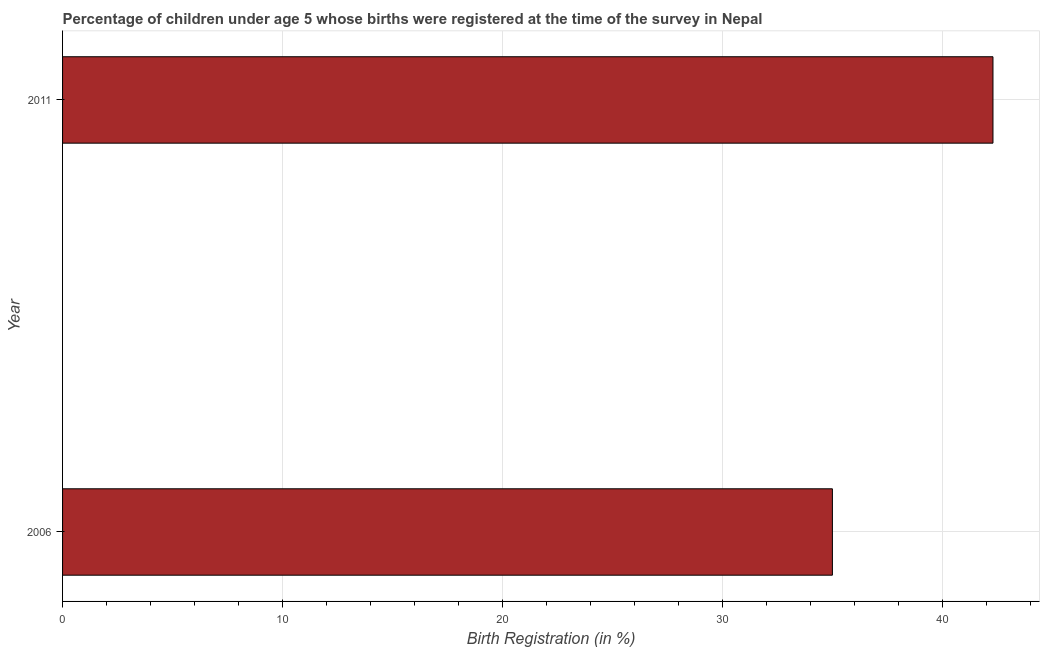Does the graph contain any zero values?
Offer a terse response. No. Does the graph contain grids?
Ensure brevity in your answer.  Yes. What is the title of the graph?
Offer a terse response. Percentage of children under age 5 whose births were registered at the time of the survey in Nepal. What is the label or title of the X-axis?
Ensure brevity in your answer.  Birth Registration (in %). What is the label or title of the Y-axis?
Give a very brief answer. Year. What is the birth registration in 2006?
Give a very brief answer. 35. Across all years, what is the maximum birth registration?
Ensure brevity in your answer.  42.3. Across all years, what is the minimum birth registration?
Your response must be concise. 35. In which year was the birth registration minimum?
Your answer should be very brief. 2006. What is the sum of the birth registration?
Your answer should be very brief. 77.3. What is the difference between the birth registration in 2006 and 2011?
Your answer should be compact. -7.3. What is the average birth registration per year?
Ensure brevity in your answer.  38.65. What is the median birth registration?
Your response must be concise. 38.65. In how many years, is the birth registration greater than 20 %?
Your response must be concise. 2. What is the ratio of the birth registration in 2006 to that in 2011?
Keep it short and to the point. 0.83. Are all the bars in the graph horizontal?
Your answer should be very brief. Yes. What is the difference between two consecutive major ticks on the X-axis?
Provide a succinct answer. 10. Are the values on the major ticks of X-axis written in scientific E-notation?
Give a very brief answer. No. What is the Birth Registration (in %) in 2011?
Provide a succinct answer. 42.3. What is the ratio of the Birth Registration (in %) in 2006 to that in 2011?
Ensure brevity in your answer.  0.83. 